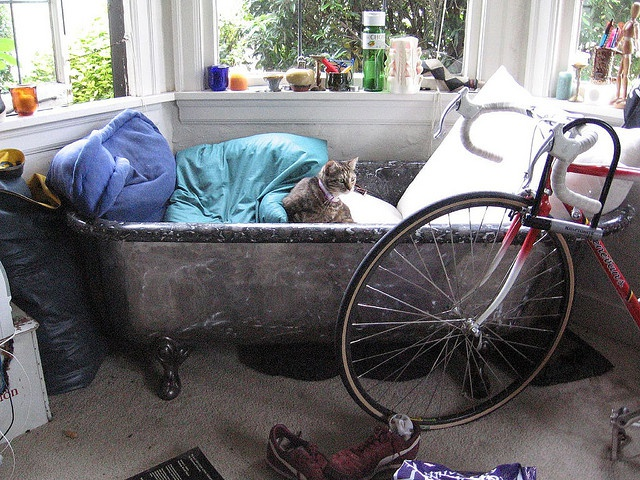Describe the objects in this image and their specific colors. I can see bicycle in white, black, gray, and darkgray tones, cat in white, gray, darkgray, and black tones, bottle in white, lightgray, green, darkgreen, and darkgray tones, cup in white, orange, and brown tones, and bowl in white, orange, and brown tones in this image. 